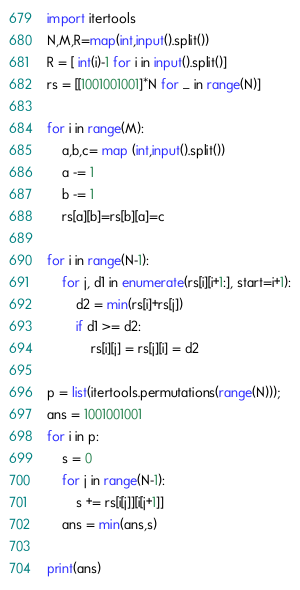<code> <loc_0><loc_0><loc_500><loc_500><_Python_>import itertools
N,M,R=map(int,input().split())
R = [ int(i)-1 for i in input().split()]
rs = [[1001001001]*N for _ in range(N)]

for i in range(M):
    a,b,c= map (int,input().split())
    a -= 1
    b -= 1
    rs[a][b]=rs[b][a]=c

for i in range(N-1):
    for j, d1 in enumerate(rs[i][i+1:], start=i+1):
        d2 = min(rs[i]+rs[j])
        if d1 >= d2:
            rs[i][j] = rs[j][i] = d2

p = list(itertools.permutations(range(N)));
ans = 1001001001
for i in p:
    s = 0
    for j in range(N-1):
        s += rs[i[j]][i[j+1]]
    ans = min(ans,s)

print(ans)</code> 